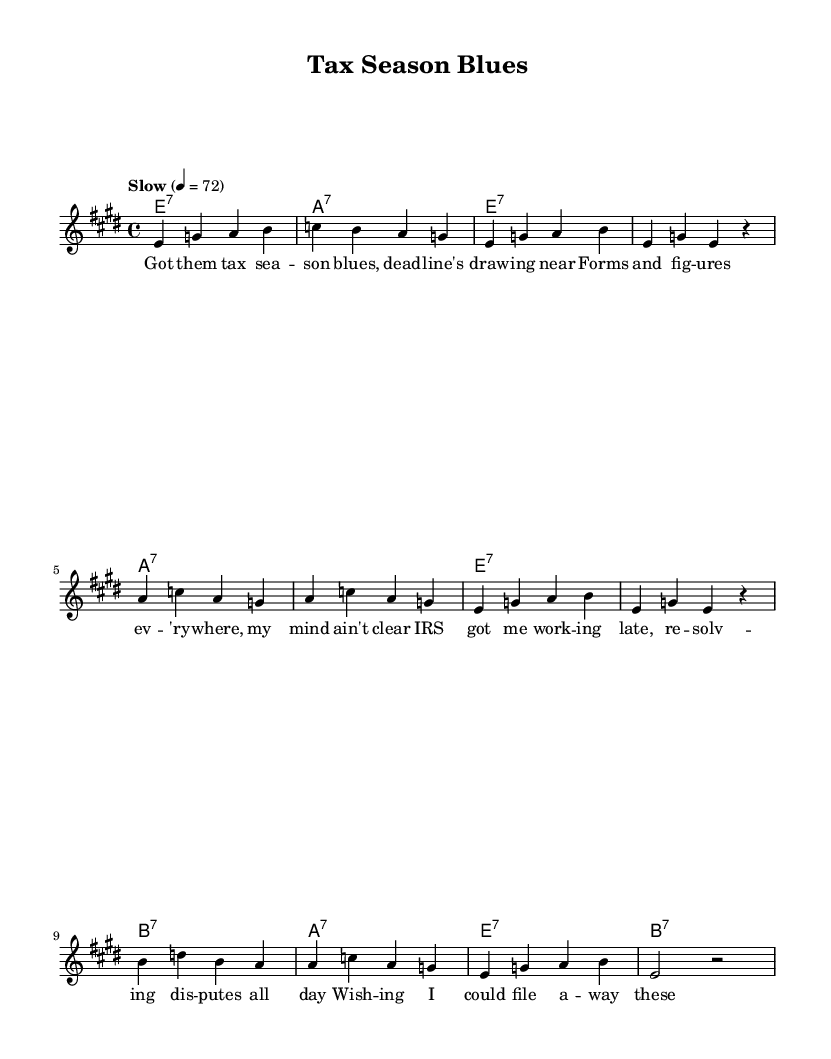What is the key signature of this music? The key signature is E major, which has four sharps (F#, C#, G#, D#). This can be determined by looking at the key specified in the global definition.
Answer: E major What is the time signature of this music? The time signature is 4/4, indicated in the global section of the code. This means there are four beats in each measure and the quarter note gets one beat.
Answer: 4/4 What is the tempo marking of this piece? The tempo marking indicated is "Slow" with a tempo of 72 beats per minute. This is mentioned in the global section as a tempo directive.
Answer: Slow How many measures are there in the melody? The melody consists of 12 measures, which can be counted by observing the bars in the melody notation provided in the code.
Answer: 12 What is the starting note of the melody? The starting note of the melody is E, which is the first note listed in the melody section (`e4`).
Answer: E What type of chord progression is used in this piece? The chords used follow a standard 12-bar blues progression, suggested by the sequence of E7, A7, and B7 chords in the harmonies section. This reflection of a blues form is characteristic of the genre.
Answer: 12-bar blues What lyric reflects the tax season theme? The lyric "Got them tax sea -- son blues, dead -- line's draw -- ing near" directly expresses the theme of tax season woes and pressures. It captures the essence of the subject matter effectively.
Answer: "Got them tax sea -- son blues" 